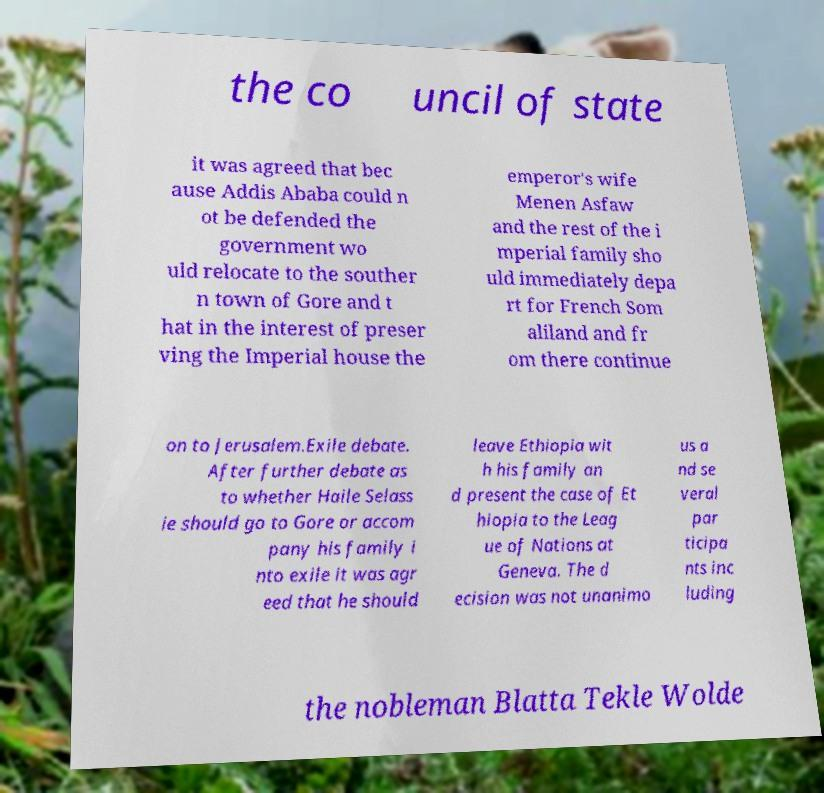Please read and relay the text visible in this image. What does it say? the co uncil of state it was agreed that bec ause Addis Ababa could n ot be defended the government wo uld relocate to the souther n town of Gore and t hat in the interest of preser ving the Imperial house the emperor's wife Menen Asfaw and the rest of the i mperial family sho uld immediately depa rt for French Som aliland and fr om there continue on to Jerusalem.Exile debate. After further debate as to whether Haile Selass ie should go to Gore or accom pany his family i nto exile it was agr eed that he should leave Ethiopia wit h his family an d present the case of Et hiopia to the Leag ue of Nations at Geneva. The d ecision was not unanimo us a nd se veral par ticipa nts inc luding the nobleman Blatta Tekle Wolde 